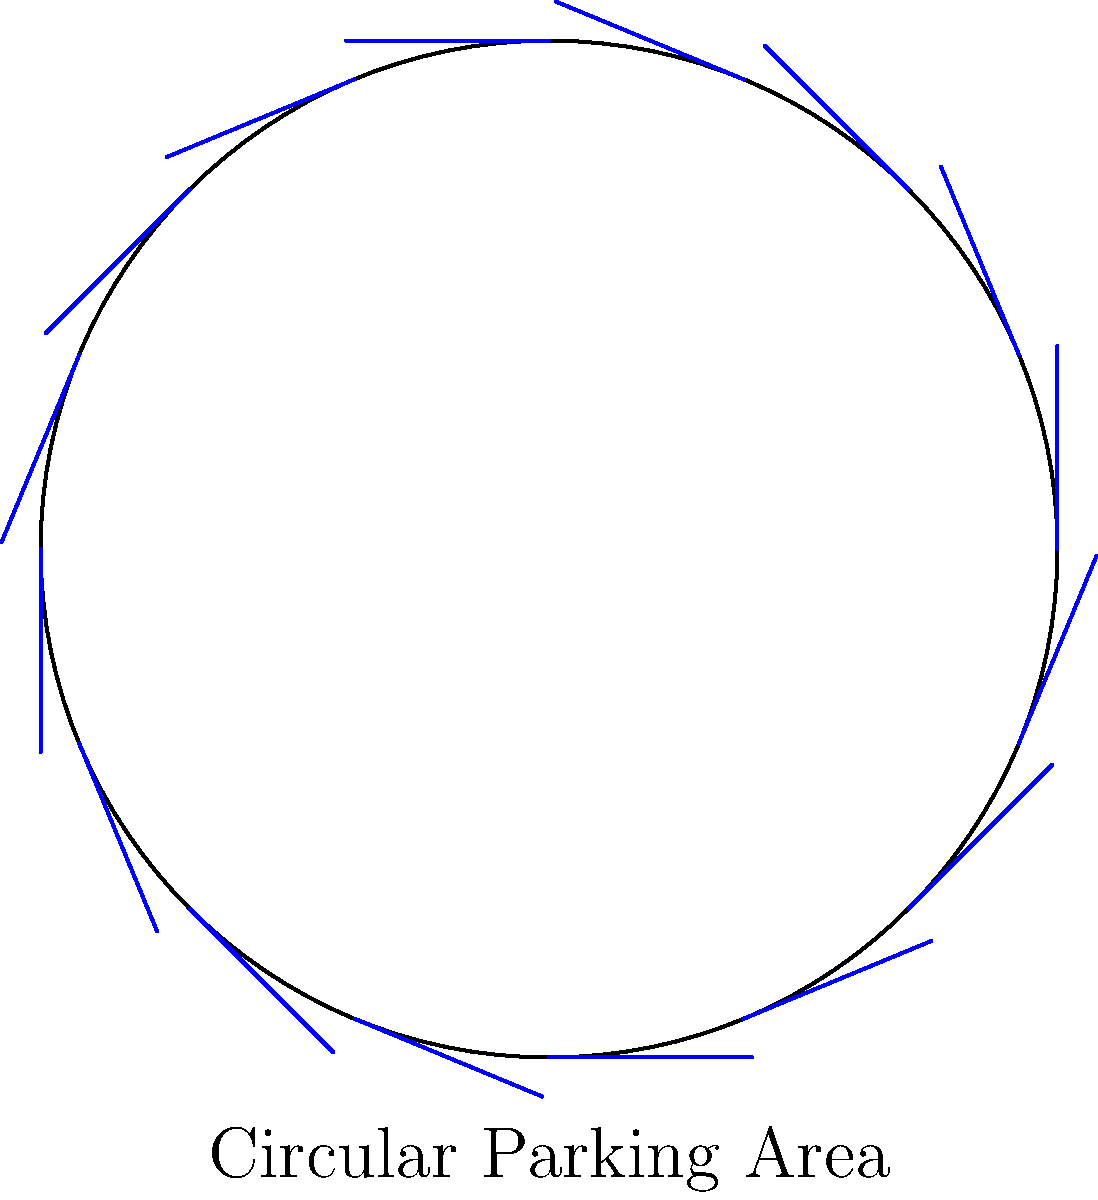A circular parking area has a diameter of 30 meters. If each car occupies 6 meters of space along the circumference, how many cars can be parked around the edge of this circular area? To solve this problem, we need to follow these steps:

1. Calculate the circumference of the circular parking area:
   - Diameter = 30 meters
   - Radius = Diameter / 2 = 30 / 2 = 15 meters
   - Circumference = $2\pi r = 2\pi \times 15 = 30\pi$ meters

2. Determine the space each car occupies:
   - Each car occupies 6 meters of space

3. Calculate the number of cars that can fit:
   - Number of cars = Circumference / Space per car
   - Number of cars = $30\pi / 6 = 5\pi$

4. Round down to the nearest whole number:
   - $5\pi \approx 15.71$
   - Rounding down, we get 15 cars

Therefore, 15 cars can be parked around the edge of this circular parking area.
Answer: 15 cars 